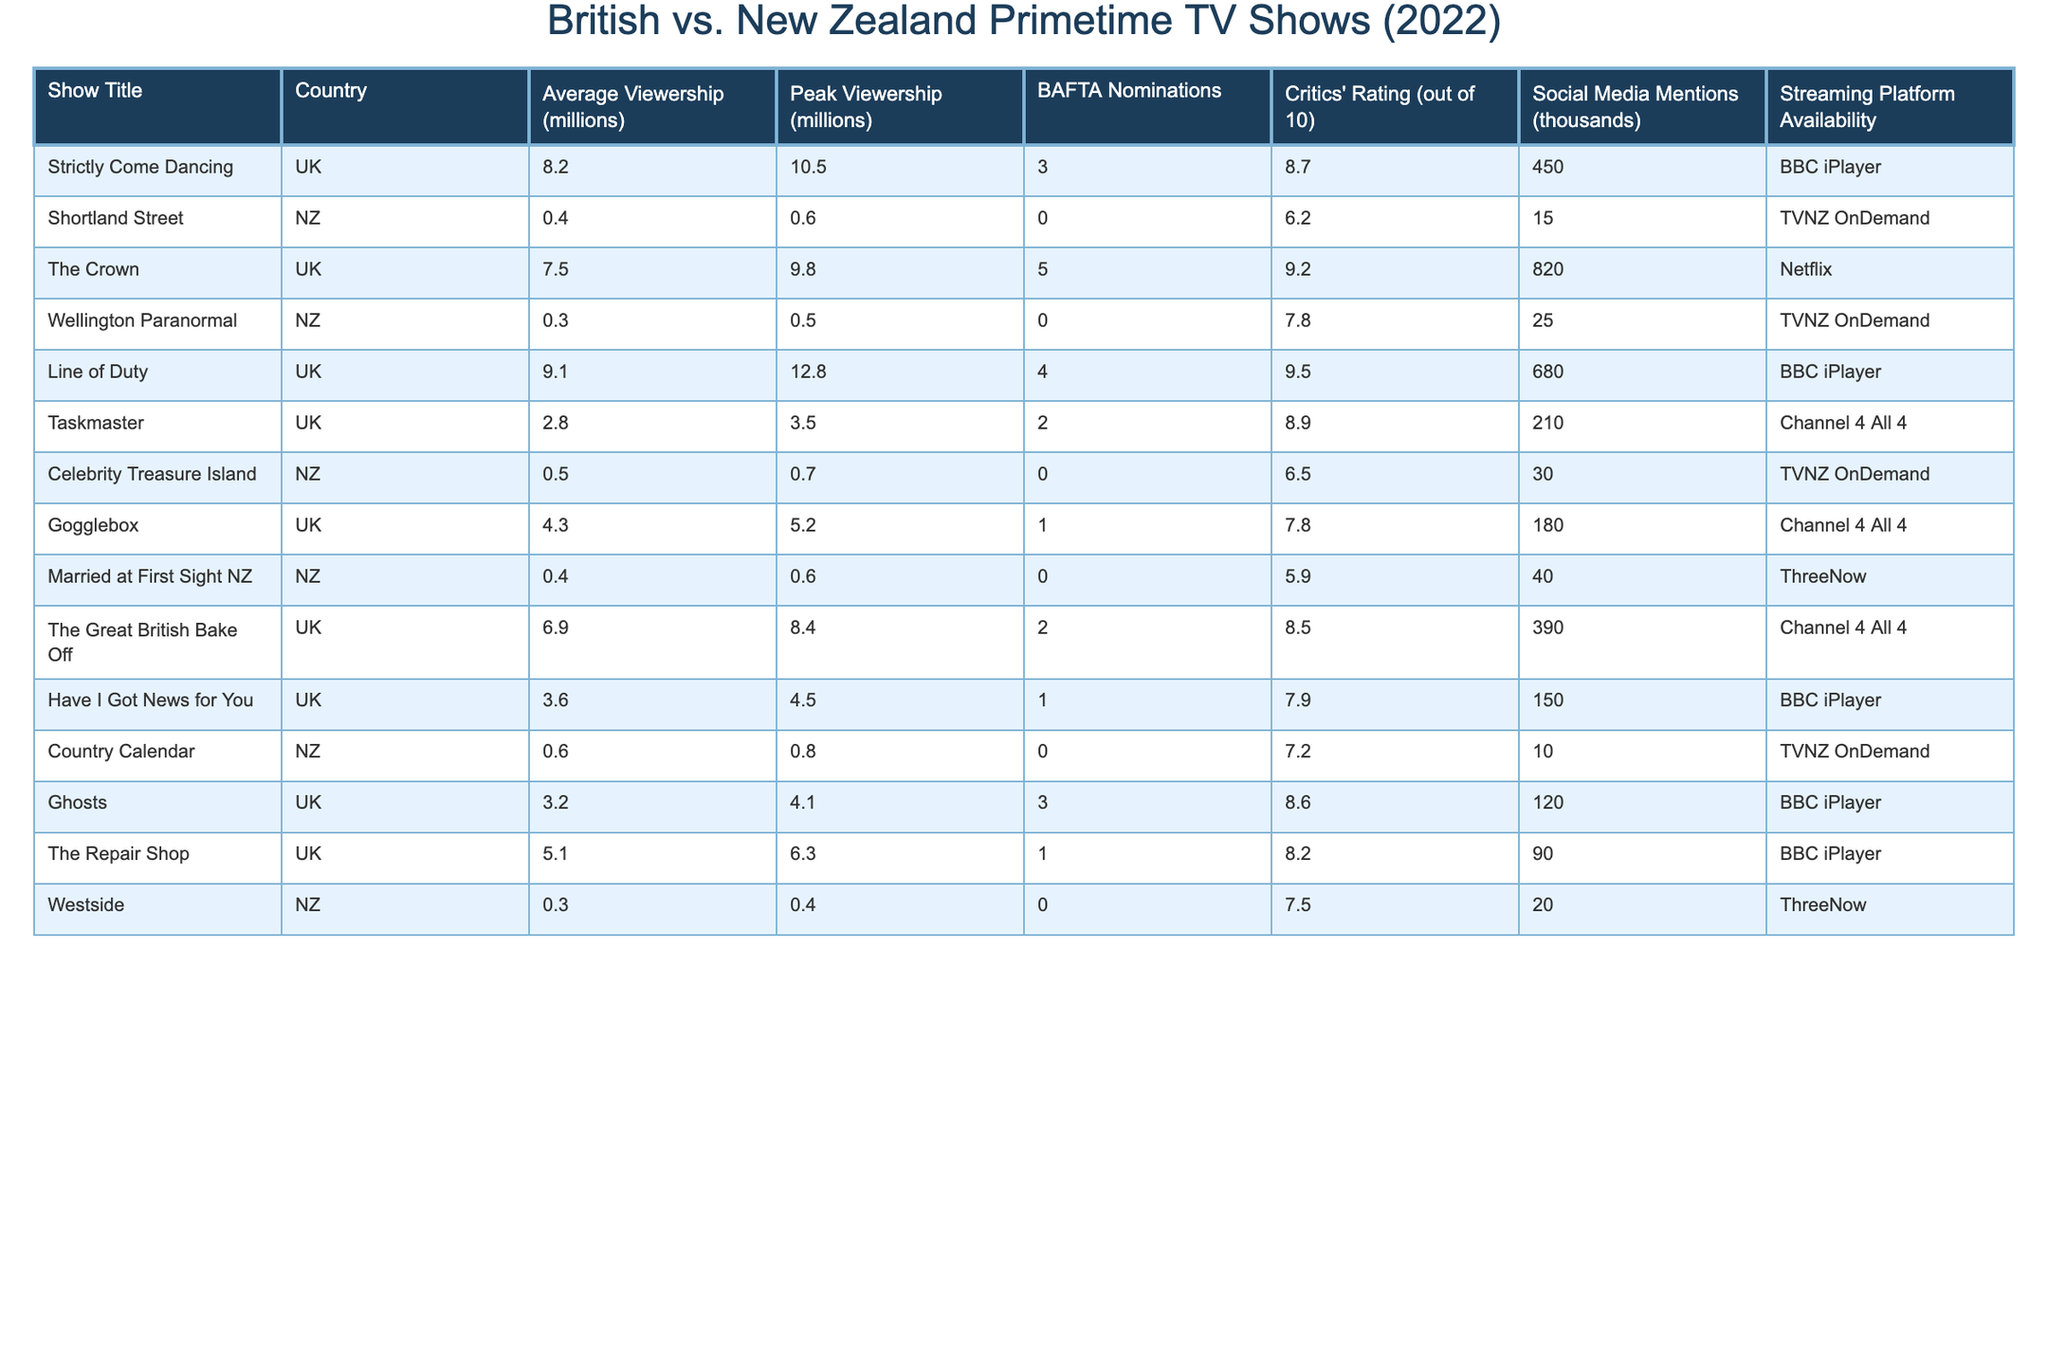What is the average viewership for "Strictly Come Dancing"? The table shows that "Strictly Come Dancing" has an average viewership of 8.2 million.
Answer: 8.2 million Which show had the highest peak viewership in the UK? According to the table, "Line of Duty" had the highest peak viewership in the UK at 12.8 million.
Answer: 12.8 million Did "Shortland Street" receive any BAFTA nominations? The table indicates that "Shortland Street" had 0 BAFTA nominations, which means it did not receive any.
Answer: No What is the average critics' rating for New Zealand shows? The critics' ratings for New Zealand shows are 6.2, 7.8, 6.5, 5.9, and 7.2. The average is (6.2 + 7.8 + 6.5 + 5.9 + 7.2) / 5 = 6.72.
Answer: 6.72 How many BAFTA nominations do all UK shows combined have? The total BAFTA nominations for UK shows are 3 (Strictly Come Dancing) + 5 (The Crown) + 4 (Line of Duty) + 2 (The Great British Bake Off) + 1 (Have I Got News for You) + 3 (Ghosts) + 1 (The Repair Shop) + 2 (Taskmaster) = 21.
Answer: 21 What is the difference in average viewership between the UK show "The Great British Bake Off" and the NZ show "Married at First Sight NZ"? "The Great British Bake Off" has an average viewership of 6.9 million while "Married at First Sight NZ" has 0.4 million. Therefore, the difference is 6.9 - 0.4 = 6.5 million.
Answer: 6.5 million Which UK show had the highest critics' rating? The table shows that "Line of Duty" has the highest critics' rating of 9.5 out of 10 among UK shows listed.
Answer: 9.5 How many shows in the table had an average viewership of less than 1 million? The shows with average viewership less than 1 million are "Wellington Paranormal," "Shortland Street," and "Westside," totaling to 3 shows.
Answer: 3 Is "Celebrity Treasure Island" available on a streaming platform? The table indicates that "Celebrity Treasure Island" is available on TVNZ OnDemand.
Answer: Yes Which show mentioned has the most social media mentions? The table specifies that "The Crown" has the most social media mentions at 820 thousand.
Answer: 820 thousand 